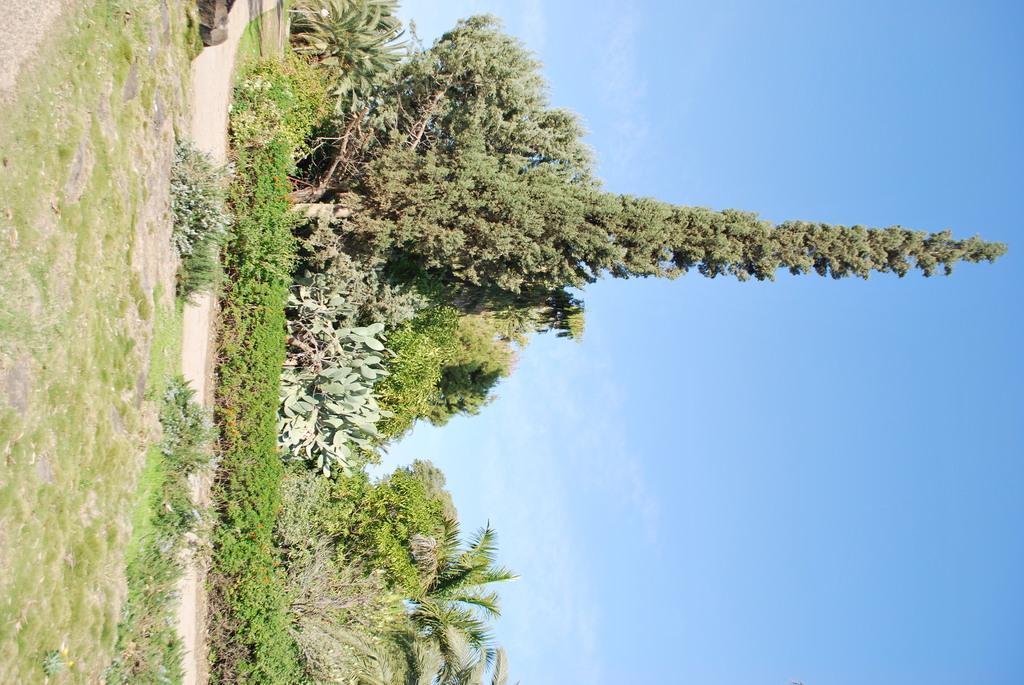Please provide a concise description of this image. This picture is clicked outside. In the foreground we can see the green grass, plants, trees and the ground. In the background we can see the sky. 